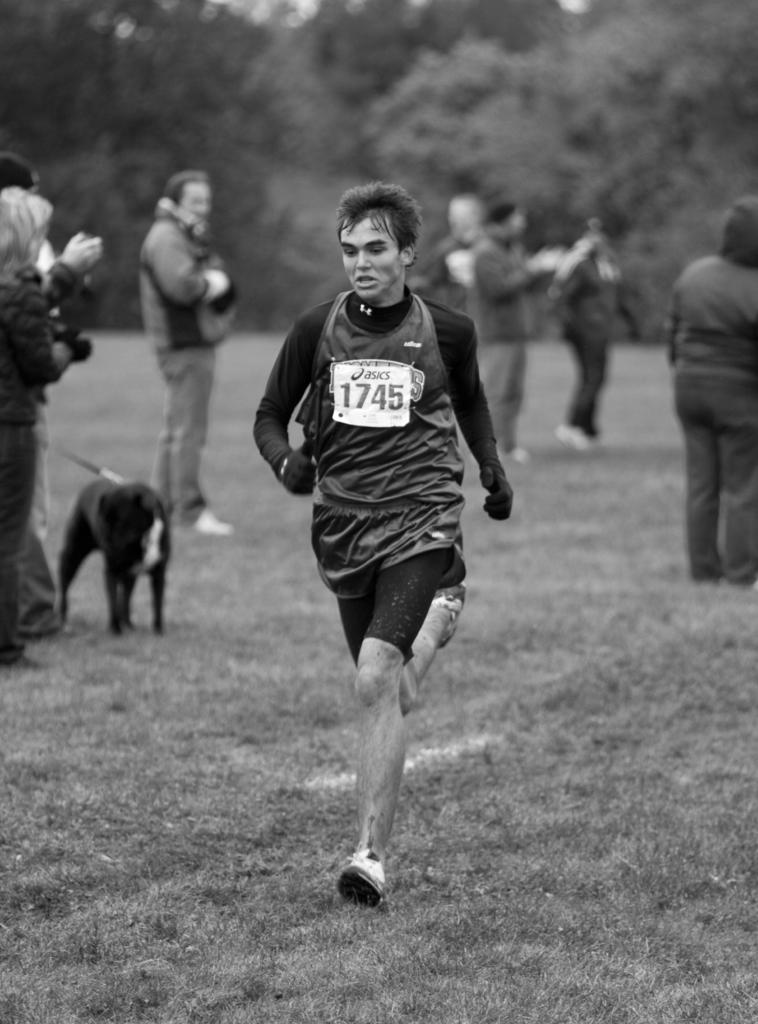What is the man in the image doing? The man is running in the image. What are the people in the image doing? The people are clapping hands in the image. Can you describe the interaction between a person and an animal in the image? Someone is holding a dog in the image. What can be seen in the background of the image? There are trees visible in the background of the image. What type of table is being used by the company in the image? There is no table or company present in the image. How many screws are visible in the image? There are no screws visible in the image. 